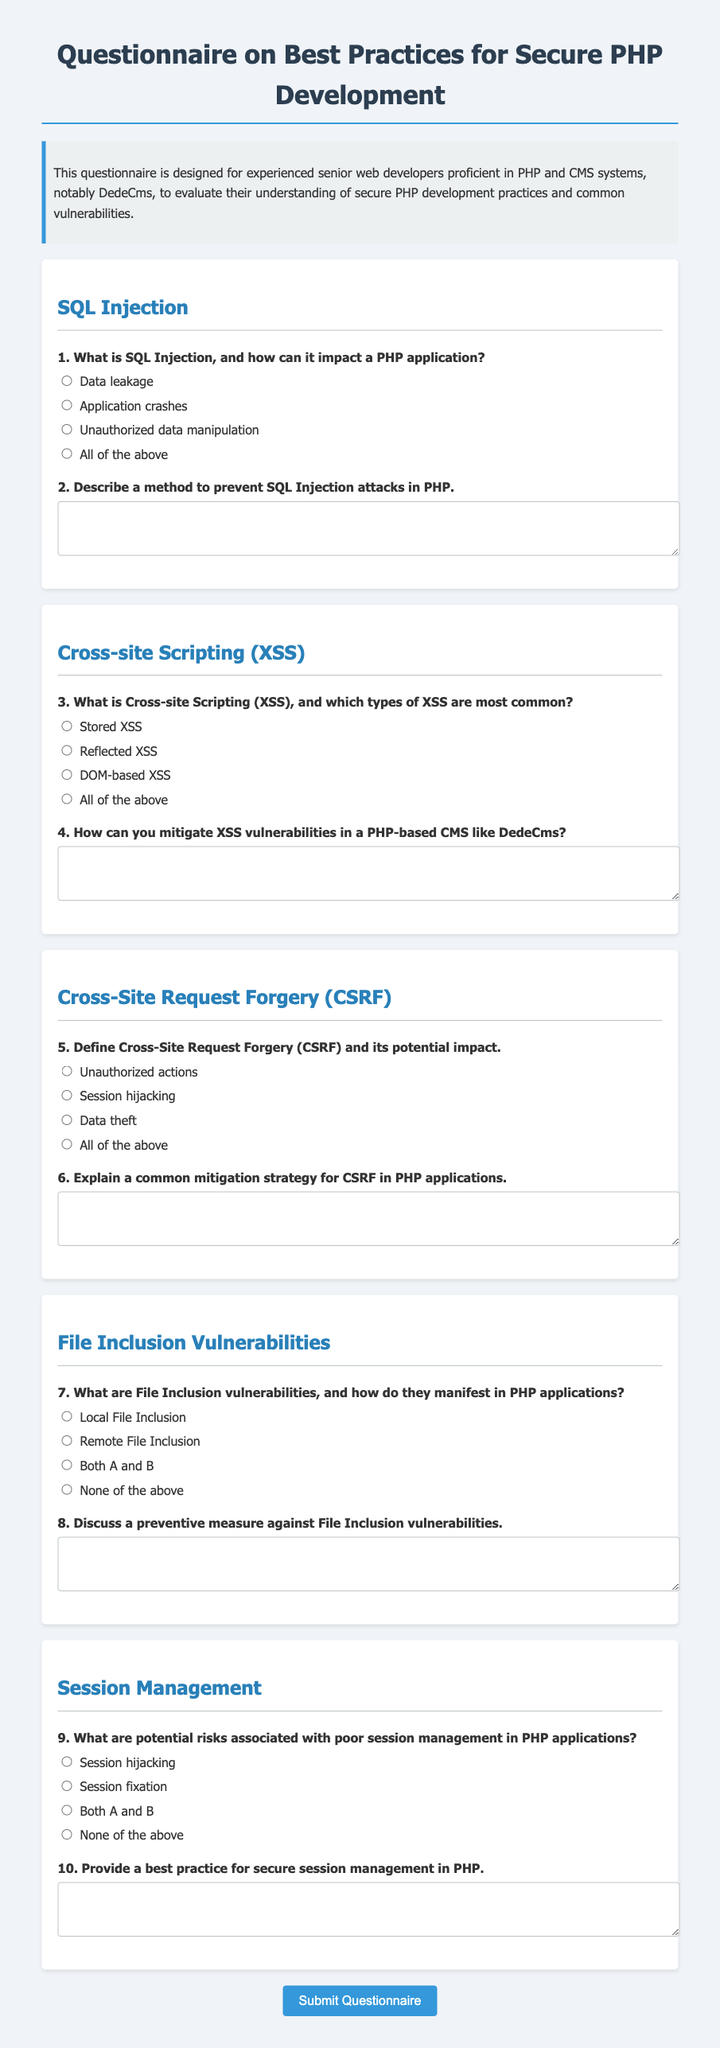What is the title of the document? The title of the document is found in the `<title>` tag of the HTML, which describes its content.
Answer: Secure PHP Development Questionnaire How many sections are there in the questionnaire? The sections are delineated in the document, each covering different vulnerabilities in secure PHP development.
Answer: Five What is one common vulnerability mentioned related to SQL? Each section lists specific vulnerabilities that are common in PHP applications, specifically in SQL.
Answer: SQL Injection What are the three types of XSS attacks listed? The document specifies different types of XSS within the section for Cross-site Scripting to elucidate the various vulnerabilities.
Answer: Stored XSS, Reflected XSS, DOM-based XSS What is the potential impact of CSRF according to the document? The document presents multiple possible impacts of CSRF, indicating the significance of understanding it.
Answer: Unauthorized actions What input format is used for describing a method to prevent SQL Injection? The document allows for open-ended responses for certain questions, which are captured in a specific format.
Answer: Textarea What best practice for secure session management is requested? The questionnaire encourages participants to provide their knowledge of best practices specifically for session management.
Answer: Open response How is the document visually structured in terms of sections? Each section is distinctly styled with headers and options, adding clarity to the questionnaire format.
Answer: Sectioned layout 